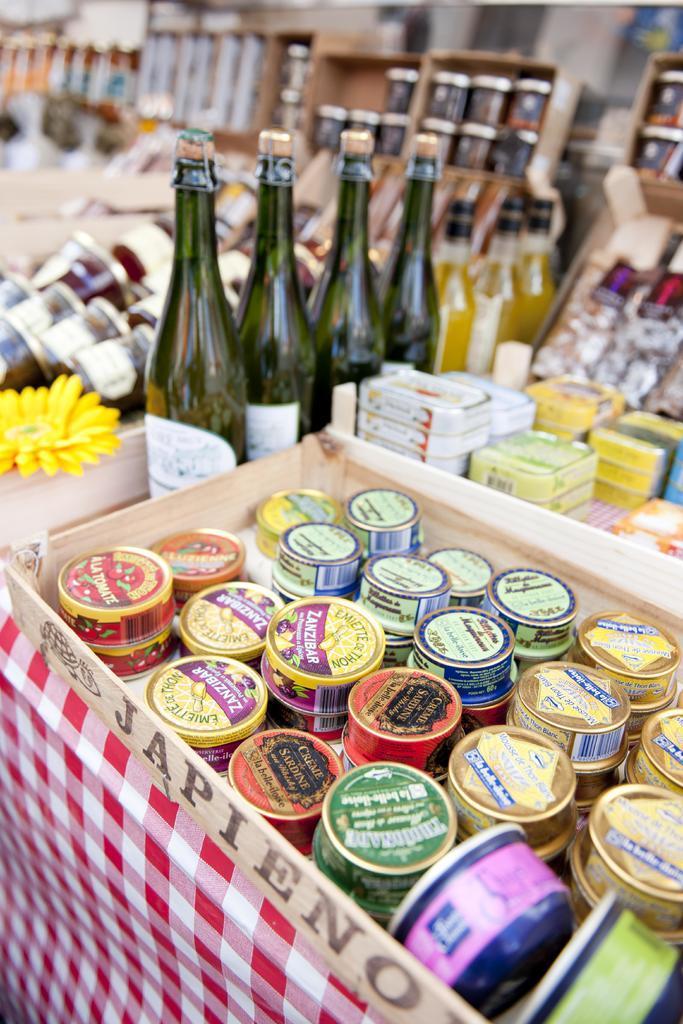How would you summarize this image in a sentence or two? In this picture there are variety of small boxes arranged in a row and there are white color boxes arranged in a straight line, there are yellow color boxes are arranged in a straight line and their also few wine bottles arranged here backdrop also there are some wine bottles, there is a flower here and there is a red and white checks cloth 